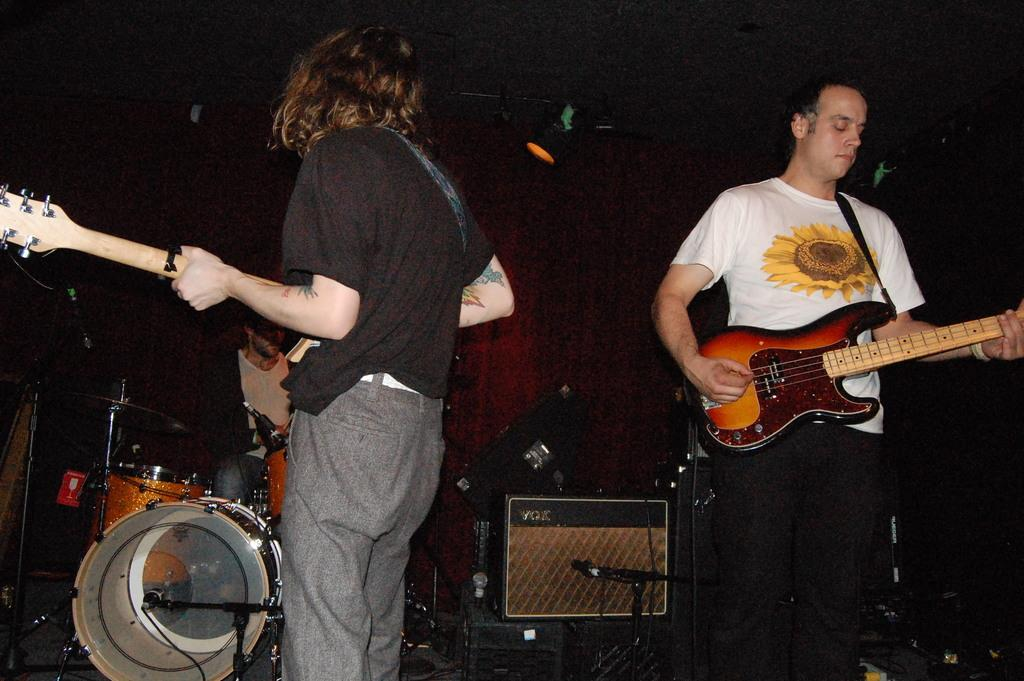How many people are in the image? There are two men in the image. What are the men doing in the image? The men are standing and playing guitar. What type of plant is growing on the company's logo in the image? There is no company or logo present in the image, and therefore no plant growing on it. 